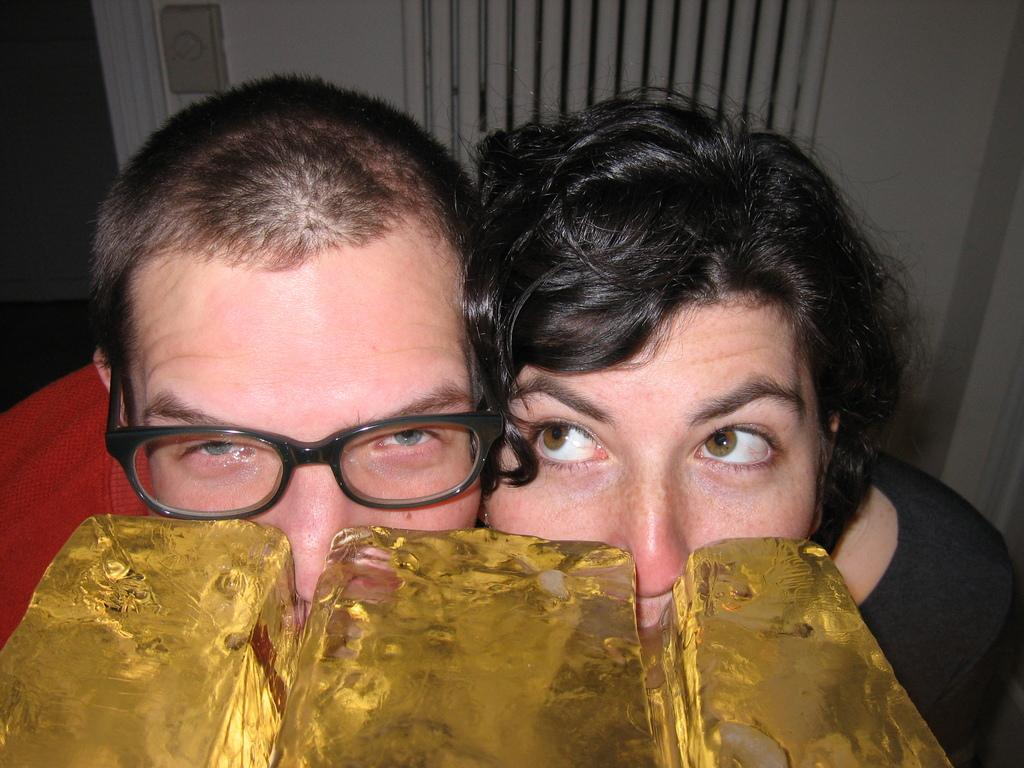How many people are in the image? There are two persons in the image. Can you describe the clothing of the person with spectacles? The person with spectacles is wearing a red t-shirt. What color is the t-shirt of the woman in the image? The woman is wearing a black t-shirt. What can be seen in the foreground of the image? In the foreground, there are ice blocks visible. What type of string can be seen tied to the woman's t-shirt in the image? There is no string tied to the woman's t-shirt in the image. Is there a bathtub visible in the image? There is no bathtub visible in the image. 